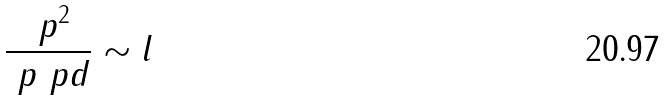<formula> <loc_0><loc_0><loc_500><loc_500>\frac { \ p ^ { 2 } } { \ p \ p d } \sim l</formula> 